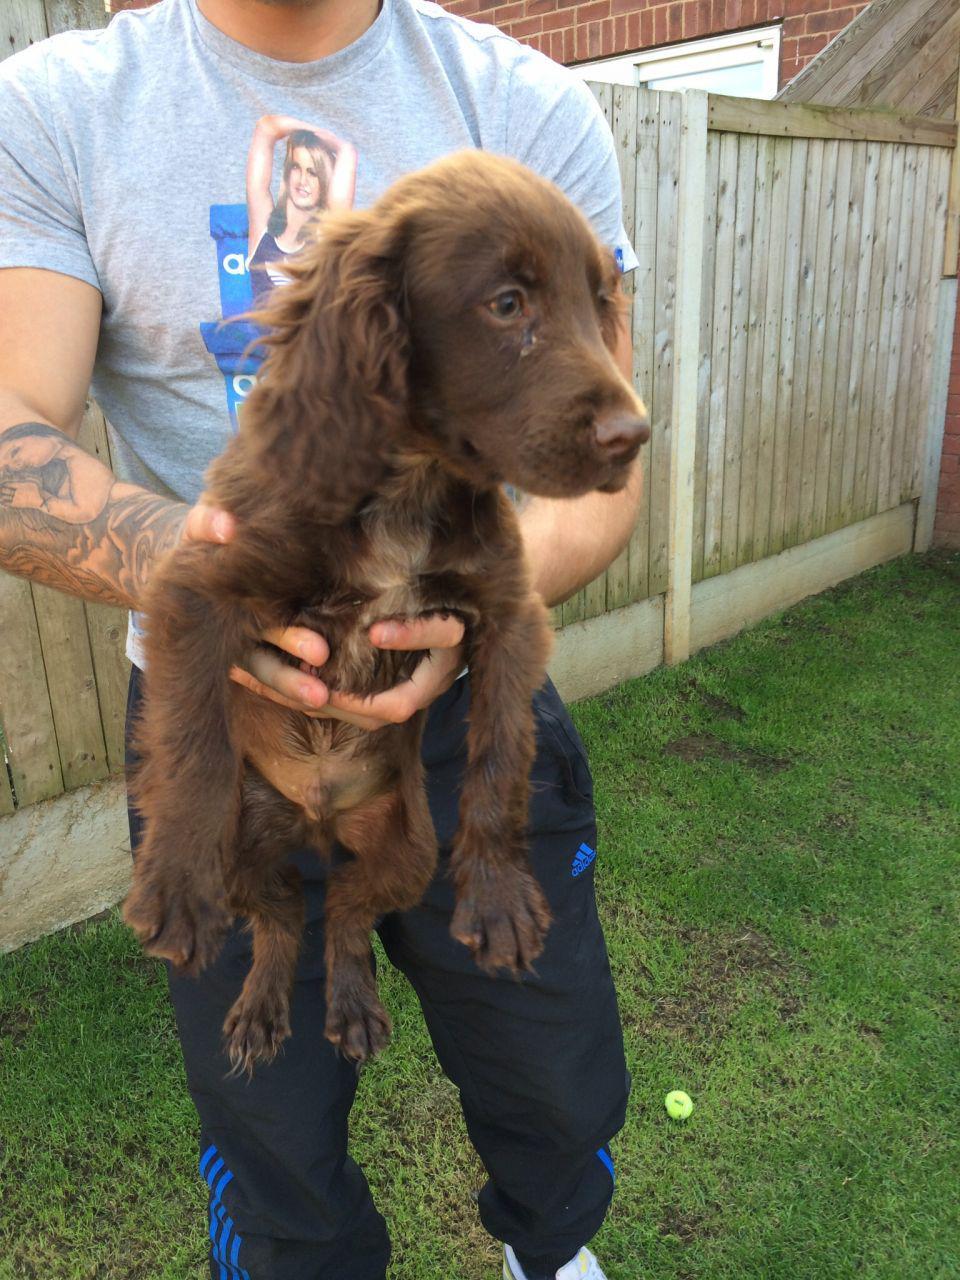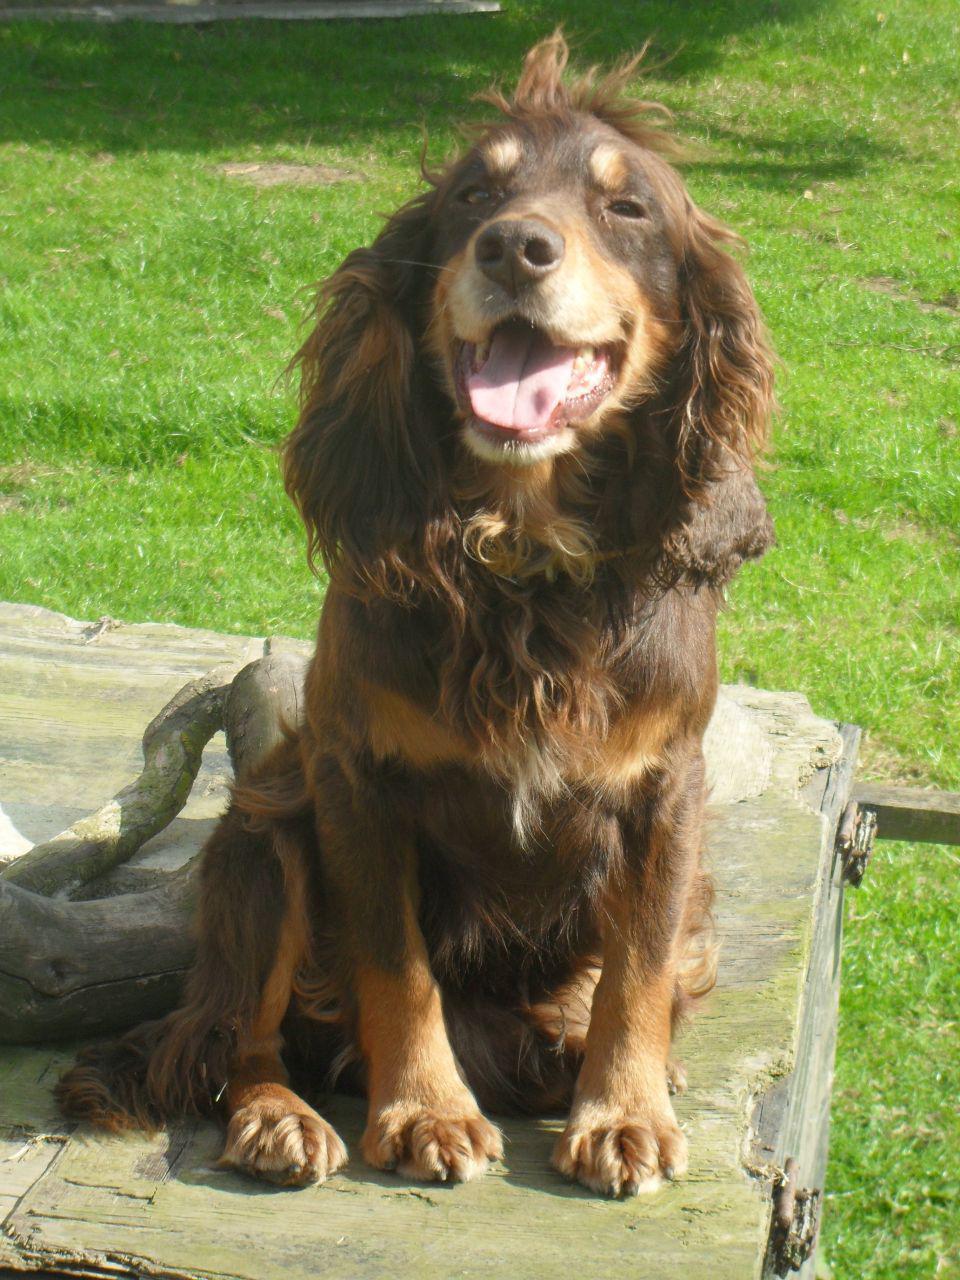The first image is the image on the left, the second image is the image on the right. Assess this claim about the two images: "A human is holding a dog in one of the images.". Correct or not? Answer yes or no. Yes. The first image is the image on the left, the second image is the image on the right. Assess this claim about the two images: "An image contains two dogs side by side.". Correct or not? Answer yes or no. No. 